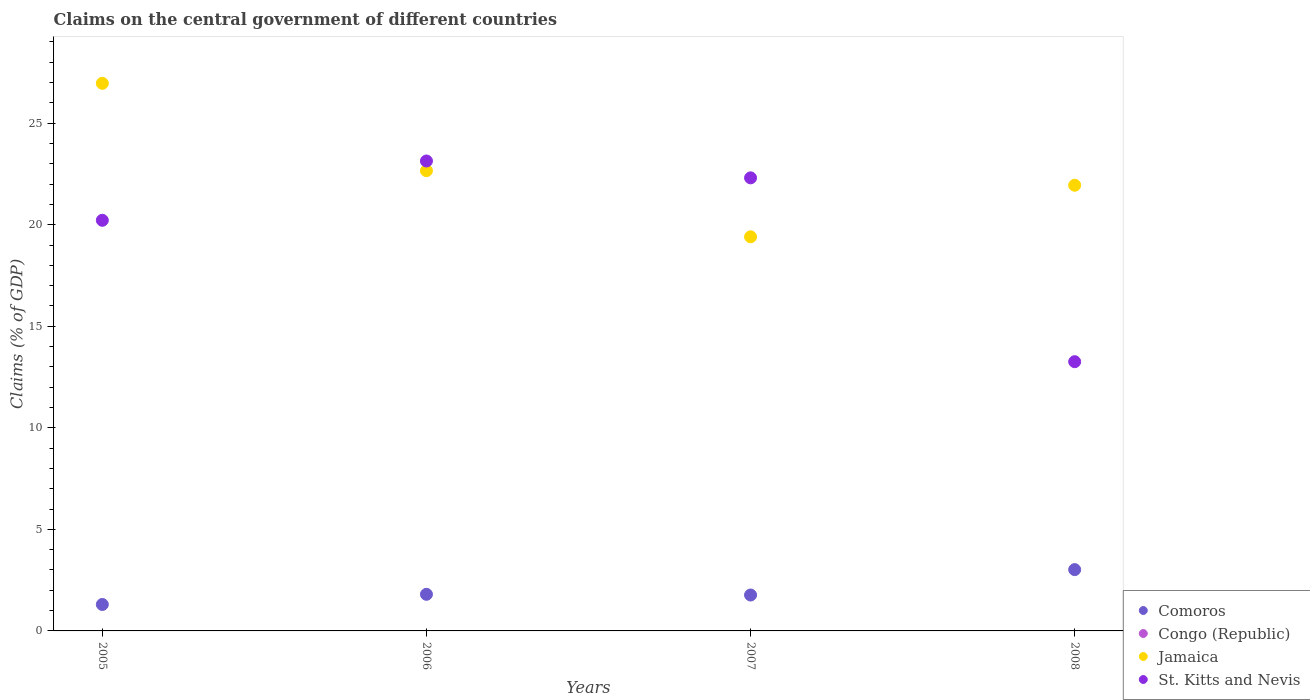Is the number of dotlines equal to the number of legend labels?
Ensure brevity in your answer.  No. What is the percentage of GDP claimed on the central government in St. Kitts and Nevis in 2007?
Provide a succinct answer. 22.31. Across all years, what is the maximum percentage of GDP claimed on the central government in Comoros?
Your answer should be compact. 3.02. In which year was the percentage of GDP claimed on the central government in Jamaica maximum?
Your answer should be compact. 2005. What is the total percentage of GDP claimed on the central government in Congo (Republic) in the graph?
Ensure brevity in your answer.  0. What is the difference between the percentage of GDP claimed on the central government in Jamaica in 2005 and that in 2007?
Offer a terse response. 7.56. What is the difference between the percentage of GDP claimed on the central government in Comoros in 2005 and the percentage of GDP claimed on the central government in Congo (Republic) in 2008?
Keep it short and to the point. 1.3. What is the average percentage of GDP claimed on the central government in Congo (Republic) per year?
Your answer should be compact. 0. In the year 2005, what is the difference between the percentage of GDP claimed on the central government in Comoros and percentage of GDP claimed on the central government in St. Kitts and Nevis?
Your answer should be very brief. -18.92. In how many years, is the percentage of GDP claimed on the central government in St. Kitts and Nevis greater than 28 %?
Offer a terse response. 0. What is the ratio of the percentage of GDP claimed on the central government in St. Kitts and Nevis in 2005 to that in 2008?
Keep it short and to the point. 1.53. What is the difference between the highest and the second highest percentage of GDP claimed on the central government in Jamaica?
Give a very brief answer. 4.3. What is the difference between the highest and the lowest percentage of GDP claimed on the central government in St. Kitts and Nevis?
Offer a terse response. 9.88. Does the percentage of GDP claimed on the central government in St. Kitts and Nevis monotonically increase over the years?
Ensure brevity in your answer.  No. Is the percentage of GDP claimed on the central government in Comoros strictly greater than the percentage of GDP claimed on the central government in Congo (Republic) over the years?
Give a very brief answer. Yes. Is the percentage of GDP claimed on the central government in Congo (Republic) strictly less than the percentage of GDP claimed on the central government in St. Kitts and Nevis over the years?
Provide a succinct answer. Yes. How many years are there in the graph?
Your response must be concise. 4. Are the values on the major ticks of Y-axis written in scientific E-notation?
Offer a terse response. No. How are the legend labels stacked?
Provide a short and direct response. Vertical. What is the title of the graph?
Provide a succinct answer. Claims on the central government of different countries. What is the label or title of the Y-axis?
Give a very brief answer. Claims (% of GDP). What is the Claims (% of GDP) of Comoros in 2005?
Your response must be concise. 1.3. What is the Claims (% of GDP) of Jamaica in 2005?
Make the answer very short. 26.96. What is the Claims (% of GDP) in St. Kitts and Nevis in 2005?
Provide a short and direct response. 20.22. What is the Claims (% of GDP) of Comoros in 2006?
Your answer should be very brief. 1.8. What is the Claims (% of GDP) in Jamaica in 2006?
Provide a succinct answer. 22.66. What is the Claims (% of GDP) of St. Kitts and Nevis in 2006?
Provide a succinct answer. 23.14. What is the Claims (% of GDP) in Comoros in 2007?
Give a very brief answer. 1.77. What is the Claims (% of GDP) in Congo (Republic) in 2007?
Make the answer very short. 0. What is the Claims (% of GDP) of Jamaica in 2007?
Ensure brevity in your answer.  19.41. What is the Claims (% of GDP) in St. Kitts and Nevis in 2007?
Your response must be concise. 22.31. What is the Claims (% of GDP) of Comoros in 2008?
Give a very brief answer. 3.02. What is the Claims (% of GDP) of Jamaica in 2008?
Your answer should be very brief. 21.94. What is the Claims (% of GDP) of St. Kitts and Nevis in 2008?
Offer a terse response. 13.26. Across all years, what is the maximum Claims (% of GDP) in Comoros?
Offer a terse response. 3.02. Across all years, what is the maximum Claims (% of GDP) of Jamaica?
Offer a very short reply. 26.96. Across all years, what is the maximum Claims (% of GDP) in St. Kitts and Nevis?
Your answer should be very brief. 23.14. Across all years, what is the minimum Claims (% of GDP) in Comoros?
Offer a very short reply. 1.3. Across all years, what is the minimum Claims (% of GDP) of Jamaica?
Provide a short and direct response. 19.41. Across all years, what is the minimum Claims (% of GDP) in St. Kitts and Nevis?
Your answer should be very brief. 13.26. What is the total Claims (% of GDP) of Comoros in the graph?
Give a very brief answer. 7.89. What is the total Claims (% of GDP) of Jamaica in the graph?
Keep it short and to the point. 90.97. What is the total Claims (% of GDP) of St. Kitts and Nevis in the graph?
Keep it short and to the point. 78.92. What is the difference between the Claims (% of GDP) of Comoros in 2005 and that in 2006?
Offer a very short reply. -0.5. What is the difference between the Claims (% of GDP) of Jamaica in 2005 and that in 2006?
Offer a very short reply. 4.3. What is the difference between the Claims (% of GDP) of St. Kitts and Nevis in 2005 and that in 2006?
Your answer should be very brief. -2.92. What is the difference between the Claims (% of GDP) of Comoros in 2005 and that in 2007?
Make the answer very short. -0.47. What is the difference between the Claims (% of GDP) of Jamaica in 2005 and that in 2007?
Ensure brevity in your answer.  7.56. What is the difference between the Claims (% of GDP) in St. Kitts and Nevis in 2005 and that in 2007?
Your response must be concise. -2.09. What is the difference between the Claims (% of GDP) in Comoros in 2005 and that in 2008?
Give a very brief answer. -1.72. What is the difference between the Claims (% of GDP) in Jamaica in 2005 and that in 2008?
Offer a terse response. 5.02. What is the difference between the Claims (% of GDP) of St. Kitts and Nevis in 2005 and that in 2008?
Keep it short and to the point. 6.96. What is the difference between the Claims (% of GDP) of Comoros in 2006 and that in 2007?
Offer a terse response. 0.04. What is the difference between the Claims (% of GDP) in Jamaica in 2006 and that in 2007?
Provide a short and direct response. 3.26. What is the difference between the Claims (% of GDP) of St. Kitts and Nevis in 2006 and that in 2007?
Make the answer very short. 0.83. What is the difference between the Claims (% of GDP) in Comoros in 2006 and that in 2008?
Your answer should be compact. -1.22. What is the difference between the Claims (% of GDP) in Jamaica in 2006 and that in 2008?
Your response must be concise. 0.72. What is the difference between the Claims (% of GDP) in St. Kitts and Nevis in 2006 and that in 2008?
Offer a very short reply. 9.88. What is the difference between the Claims (% of GDP) in Comoros in 2007 and that in 2008?
Provide a short and direct response. -1.25. What is the difference between the Claims (% of GDP) in Jamaica in 2007 and that in 2008?
Ensure brevity in your answer.  -2.54. What is the difference between the Claims (% of GDP) in St. Kitts and Nevis in 2007 and that in 2008?
Keep it short and to the point. 9.05. What is the difference between the Claims (% of GDP) in Comoros in 2005 and the Claims (% of GDP) in Jamaica in 2006?
Offer a very short reply. -21.36. What is the difference between the Claims (% of GDP) of Comoros in 2005 and the Claims (% of GDP) of St. Kitts and Nevis in 2006?
Offer a terse response. -21.84. What is the difference between the Claims (% of GDP) of Jamaica in 2005 and the Claims (% of GDP) of St. Kitts and Nevis in 2006?
Provide a short and direct response. 3.82. What is the difference between the Claims (% of GDP) of Comoros in 2005 and the Claims (% of GDP) of Jamaica in 2007?
Your answer should be very brief. -18.1. What is the difference between the Claims (% of GDP) in Comoros in 2005 and the Claims (% of GDP) in St. Kitts and Nevis in 2007?
Your response must be concise. -21.01. What is the difference between the Claims (% of GDP) of Jamaica in 2005 and the Claims (% of GDP) of St. Kitts and Nevis in 2007?
Your answer should be very brief. 4.65. What is the difference between the Claims (% of GDP) in Comoros in 2005 and the Claims (% of GDP) in Jamaica in 2008?
Your response must be concise. -20.64. What is the difference between the Claims (% of GDP) in Comoros in 2005 and the Claims (% of GDP) in St. Kitts and Nevis in 2008?
Keep it short and to the point. -11.95. What is the difference between the Claims (% of GDP) in Jamaica in 2005 and the Claims (% of GDP) in St. Kitts and Nevis in 2008?
Give a very brief answer. 13.71. What is the difference between the Claims (% of GDP) in Comoros in 2006 and the Claims (% of GDP) in Jamaica in 2007?
Give a very brief answer. -17.6. What is the difference between the Claims (% of GDP) of Comoros in 2006 and the Claims (% of GDP) of St. Kitts and Nevis in 2007?
Your answer should be compact. -20.51. What is the difference between the Claims (% of GDP) in Jamaica in 2006 and the Claims (% of GDP) in St. Kitts and Nevis in 2007?
Keep it short and to the point. 0.35. What is the difference between the Claims (% of GDP) of Comoros in 2006 and the Claims (% of GDP) of Jamaica in 2008?
Your answer should be very brief. -20.14. What is the difference between the Claims (% of GDP) in Comoros in 2006 and the Claims (% of GDP) in St. Kitts and Nevis in 2008?
Your response must be concise. -11.45. What is the difference between the Claims (% of GDP) of Jamaica in 2006 and the Claims (% of GDP) of St. Kitts and Nevis in 2008?
Ensure brevity in your answer.  9.4. What is the difference between the Claims (% of GDP) of Comoros in 2007 and the Claims (% of GDP) of Jamaica in 2008?
Your response must be concise. -20.18. What is the difference between the Claims (% of GDP) of Comoros in 2007 and the Claims (% of GDP) of St. Kitts and Nevis in 2008?
Offer a terse response. -11.49. What is the difference between the Claims (% of GDP) of Jamaica in 2007 and the Claims (% of GDP) of St. Kitts and Nevis in 2008?
Make the answer very short. 6.15. What is the average Claims (% of GDP) of Comoros per year?
Your response must be concise. 1.97. What is the average Claims (% of GDP) in Jamaica per year?
Offer a very short reply. 22.74. What is the average Claims (% of GDP) of St. Kitts and Nevis per year?
Keep it short and to the point. 19.73. In the year 2005, what is the difference between the Claims (% of GDP) of Comoros and Claims (% of GDP) of Jamaica?
Provide a succinct answer. -25.66. In the year 2005, what is the difference between the Claims (% of GDP) in Comoros and Claims (% of GDP) in St. Kitts and Nevis?
Your response must be concise. -18.92. In the year 2005, what is the difference between the Claims (% of GDP) in Jamaica and Claims (% of GDP) in St. Kitts and Nevis?
Your response must be concise. 6.74. In the year 2006, what is the difference between the Claims (% of GDP) in Comoros and Claims (% of GDP) in Jamaica?
Provide a succinct answer. -20.86. In the year 2006, what is the difference between the Claims (% of GDP) in Comoros and Claims (% of GDP) in St. Kitts and Nevis?
Offer a terse response. -21.34. In the year 2006, what is the difference between the Claims (% of GDP) in Jamaica and Claims (% of GDP) in St. Kitts and Nevis?
Your answer should be very brief. -0.48. In the year 2007, what is the difference between the Claims (% of GDP) of Comoros and Claims (% of GDP) of Jamaica?
Your response must be concise. -17.64. In the year 2007, what is the difference between the Claims (% of GDP) in Comoros and Claims (% of GDP) in St. Kitts and Nevis?
Your answer should be compact. -20.54. In the year 2007, what is the difference between the Claims (% of GDP) of Jamaica and Claims (% of GDP) of St. Kitts and Nevis?
Keep it short and to the point. -2.9. In the year 2008, what is the difference between the Claims (% of GDP) of Comoros and Claims (% of GDP) of Jamaica?
Offer a very short reply. -18.93. In the year 2008, what is the difference between the Claims (% of GDP) in Comoros and Claims (% of GDP) in St. Kitts and Nevis?
Provide a succinct answer. -10.24. In the year 2008, what is the difference between the Claims (% of GDP) of Jamaica and Claims (% of GDP) of St. Kitts and Nevis?
Make the answer very short. 8.69. What is the ratio of the Claims (% of GDP) in Comoros in 2005 to that in 2006?
Your answer should be very brief. 0.72. What is the ratio of the Claims (% of GDP) of Jamaica in 2005 to that in 2006?
Provide a succinct answer. 1.19. What is the ratio of the Claims (% of GDP) of St. Kitts and Nevis in 2005 to that in 2006?
Offer a very short reply. 0.87. What is the ratio of the Claims (% of GDP) of Comoros in 2005 to that in 2007?
Ensure brevity in your answer.  0.74. What is the ratio of the Claims (% of GDP) in Jamaica in 2005 to that in 2007?
Provide a short and direct response. 1.39. What is the ratio of the Claims (% of GDP) of St. Kitts and Nevis in 2005 to that in 2007?
Provide a short and direct response. 0.91. What is the ratio of the Claims (% of GDP) in Comoros in 2005 to that in 2008?
Provide a succinct answer. 0.43. What is the ratio of the Claims (% of GDP) in Jamaica in 2005 to that in 2008?
Ensure brevity in your answer.  1.23. What is the ratio of the Claims (% of GDP) in St. Kitts and Nevis in 2005 to that in 2008?
Give a very brief answer. 1.53. What is the ratio of the Claims (% of GDP) in Comoros in 2006 to that in 2007?
Your answer should be very brief. 1.02. What is the ratio of the Claims (% of GDP) of Jamaica in 2006 to that in 2007?
Ensure brevity in your answer.  1.17. What is the ratio of the Claims (% of GDP) of St. Kitts and Nevis in 2006 to that in 2007?
Make the answer very short. 1.04. What is the ratio of the Claims (% of GDP) of Comoros in 2006 to that in 2008?
Your response must be concise. 0.6. What is the ratio of the Claims (% of GDP) in Jamaica in 2006 to that in 2008?
Make the answer very short. 1.03. What is the ratio of the Claims (% of GDP) in St. Kitts and Nevis in 2006 to that in 2008?
Provide a succinct answer. 1.75. What is the ratio of the Claims (% of GDP) of Comoros in 2007 to that in 2008?
Your answer should be compact. 0.59. What is the ratio of the Claims (% of GDP) in Jamaica in 2007 to that in 2008?
Your answer should be very brief. 0.88. What is the ratio of the Claims (% of GDP) of St. Kitts and Nevis in 2007 to that in 2008?
Offer a very short reply. 1.68. What is the difference between the highest and the second highest Claims (% of GDP) in Comoros?
Offer a very short reply. 1.22. What is the difference between the highest and the second highest Claims (% of GDP) of Jamaica?
Your answer should be compact. 4.3. What is the difference between the highest and the second highest Claims (% of GDP) of St. Kitts and Nevis?
Your answer should be very brief. 0.83. What is the difference between the highest and the lowest Claims (% of GDP) of Comoros?
Keep it short and to the point. 1.72. What is the difference between the highest and the lowest Claims (% of GDP) in Jamaica?
Your response must be concise. 7.56. What is the difference between the highest and the lowest Claims (% of GDP) in St. Kitts and Nevis?
Your answer should be very brief. 9.88. 